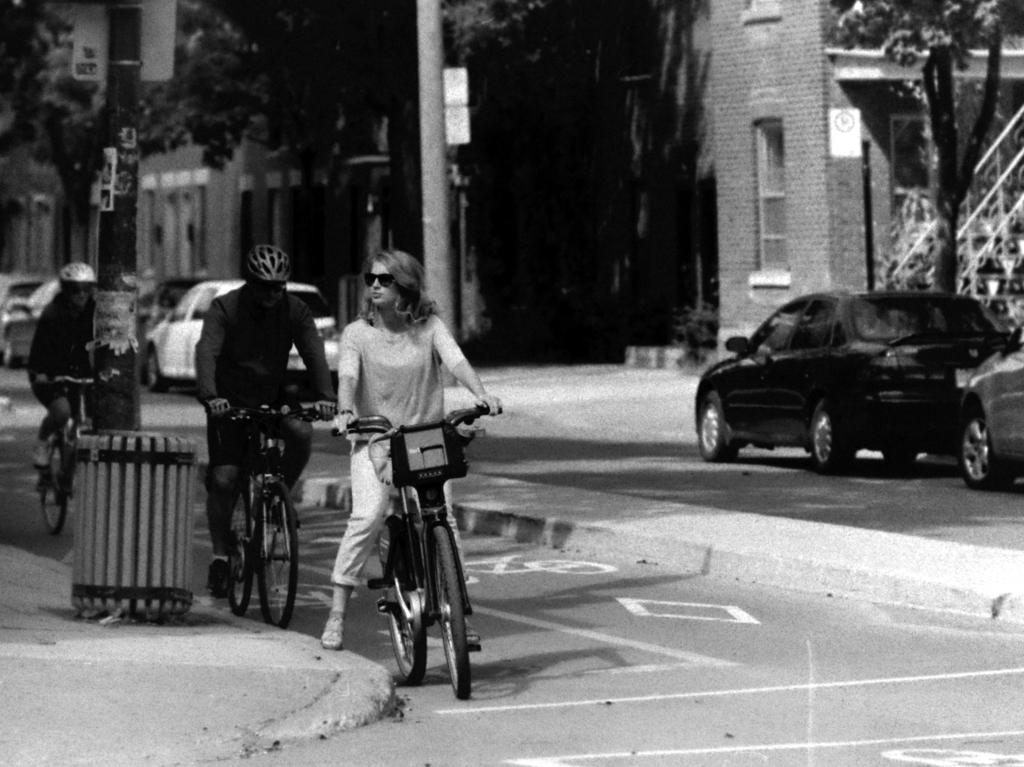How many people are in the image? There are two women and a man in the image. What are the people in the image doing? They are riding bicycles on a road. What can be seen beside the road in the image? There are cars parked beside the road. What is visible in the background of the image? There are trees and a building in the background of the image. What type of ice can be seen melting on the underwear of the man in the image? There is no ice or underwear visible in the image; the man is wearing pants and riding a bicycle. 